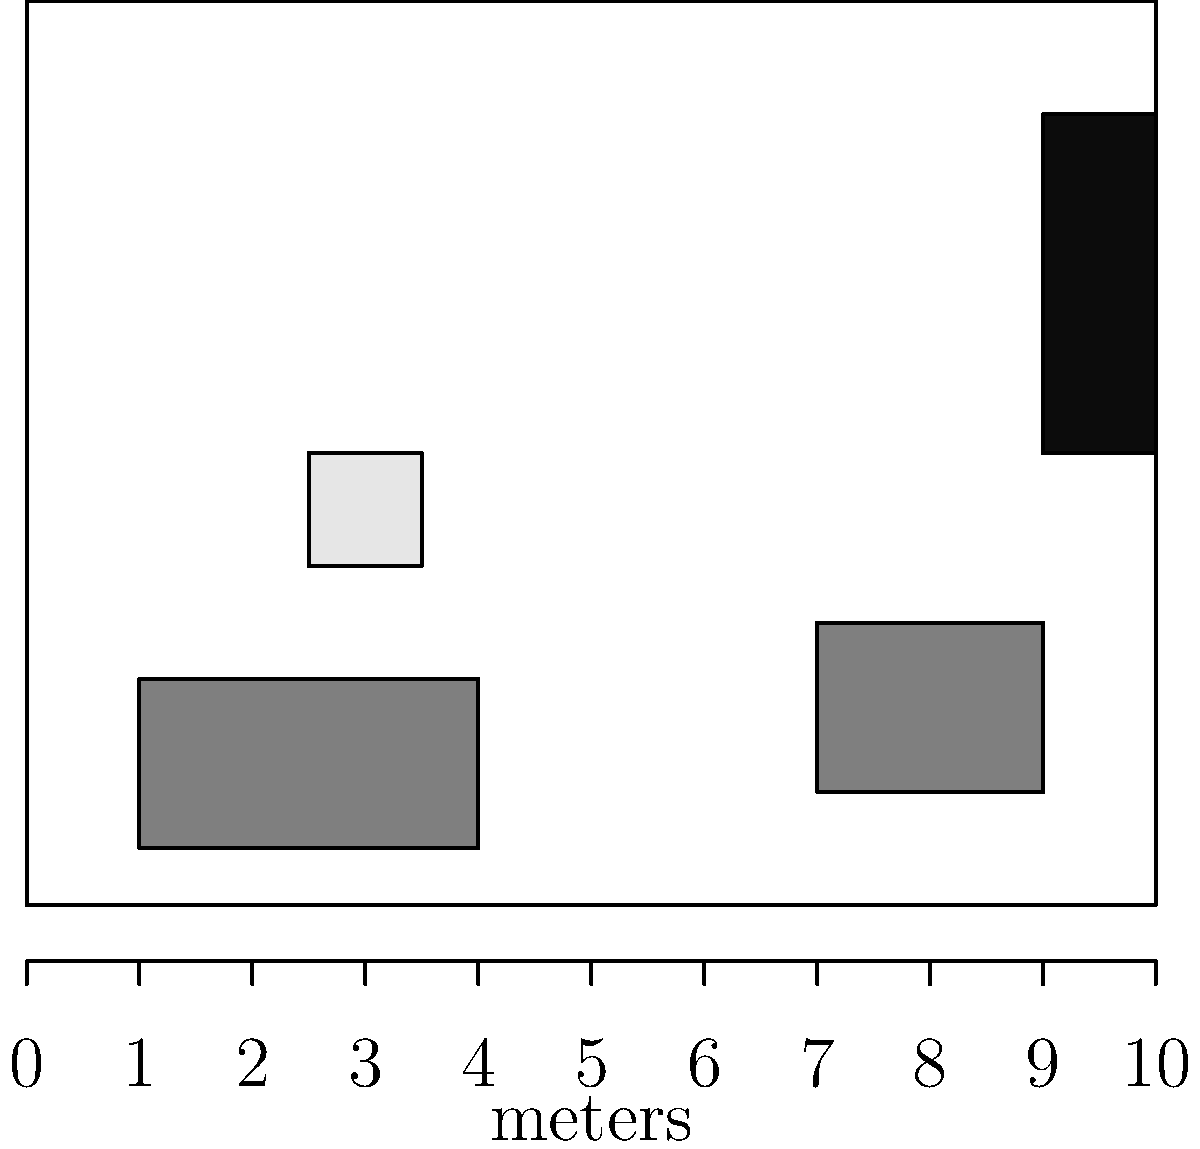Based on the furniture placement in the room shown above, estimate the dimensions of the room. The scale at the bottom is in meters. What is the approximate area of the room in square meters? To estimate the room's dimensions and calculate its area, we'll follow these steps:

1. Determine the room's width:
   - The scale shows the room is 10 meters wide.

2. Estimate the room's length:
   - We can see that the room's length is slightly less than its width.
   - Counting the grid lines, we can estimate the length to be about 8 meters.

3. Calculate the room's area:
   - Area of a rectangle = length × width
   - Estimated area = 8 m × 10 m = 80 m²

4. Verify using furniture placement:
   - The sofa appears to be about 3 meters wide, which is reasonable.
   - The armchair and bookshelf together span about 3 meters, leaving appropriate space for movement.
   - The coffee table and spaces between furniture pieces seem proportional to typical room layouts.

5. Conclude:
   The estimated dimensions of 8 m × 10 m, resulting in an area of 80 m², appear to be a reasonable approximation based on the furniture placement and scale provided.
Answer: 80 m² 